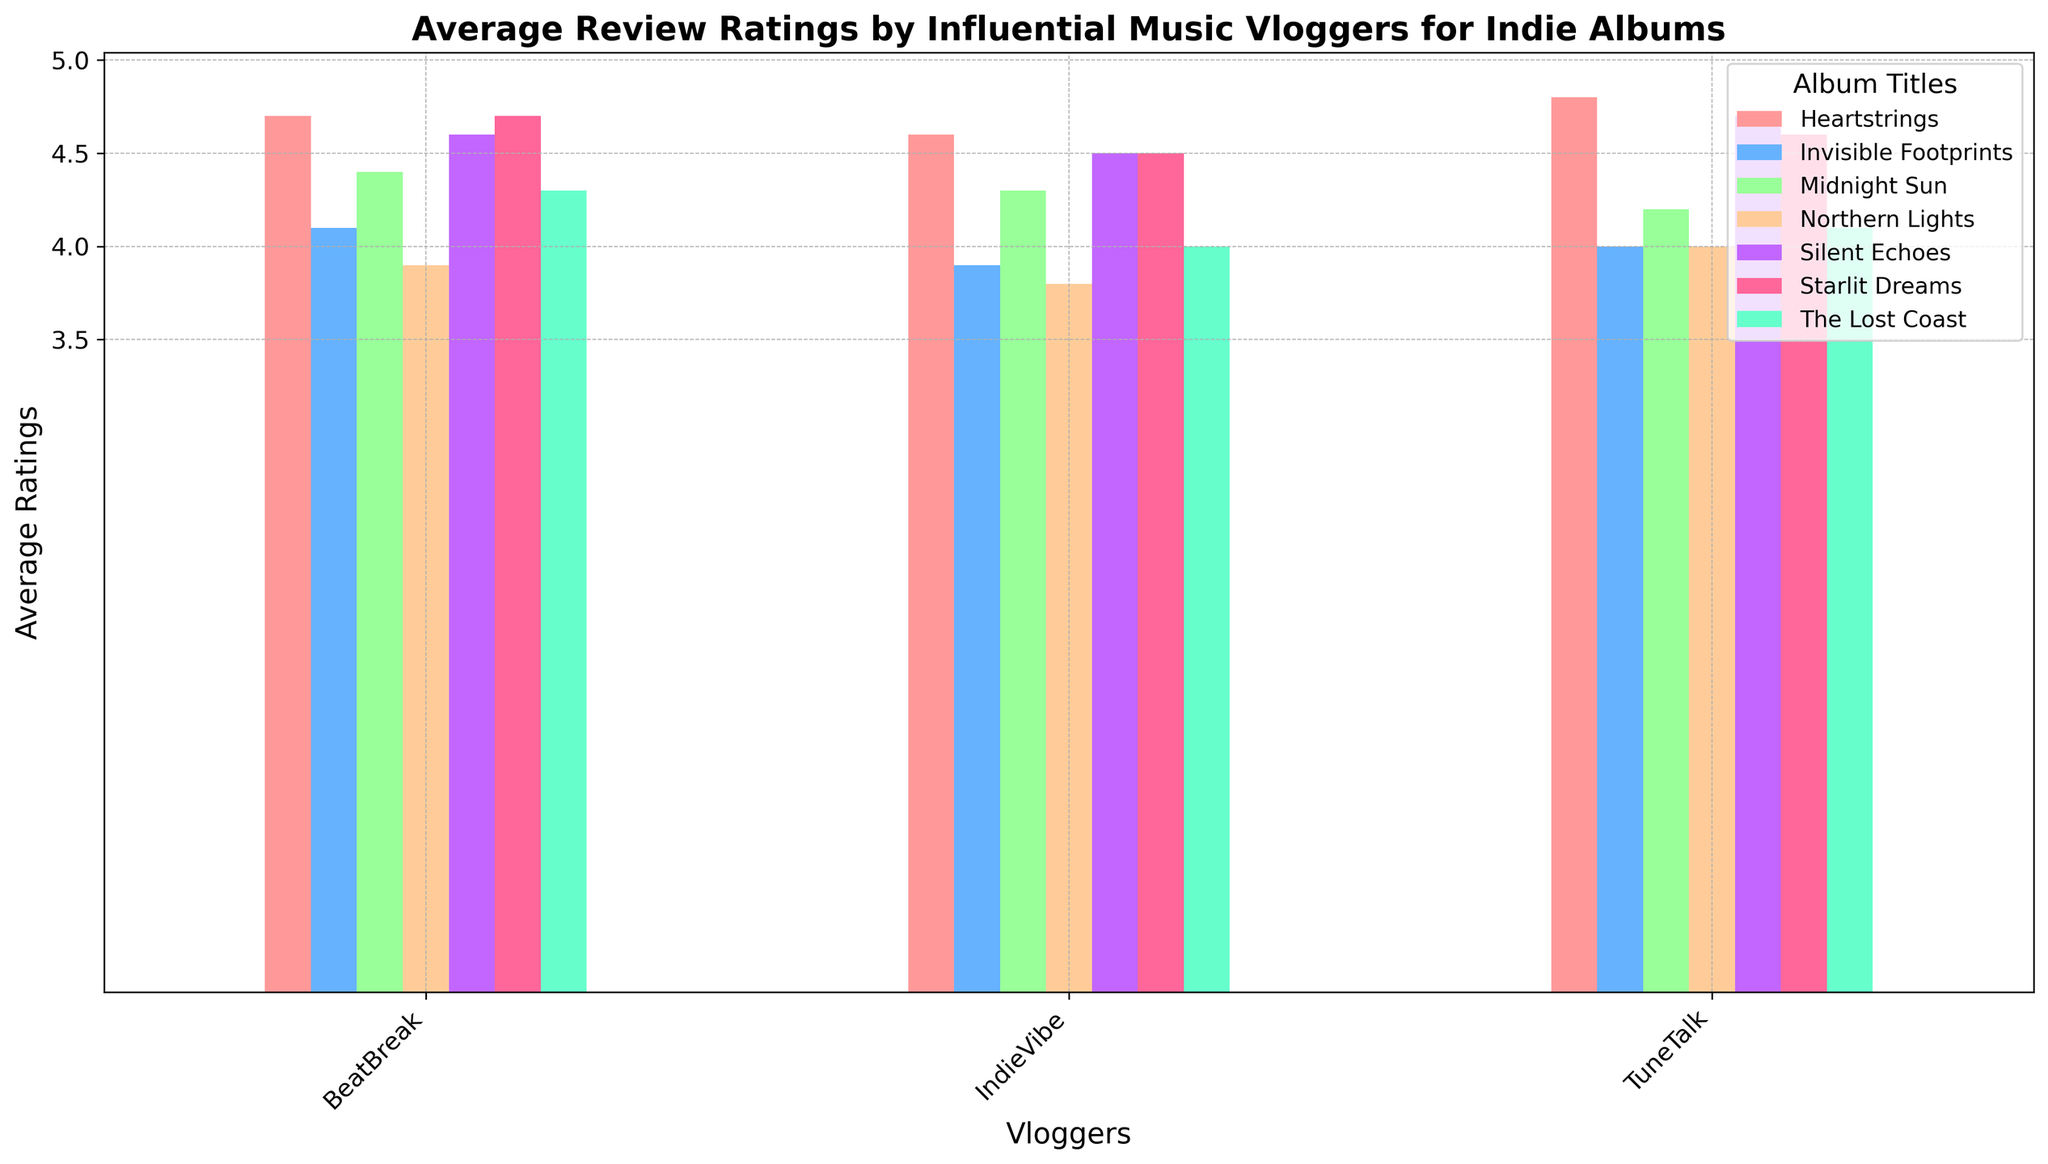What is the average rating given by IndieVibe for the album "Silent Echoes"? To find the average rating, look at the height of the bar corresponding to "Silent Echoes" for IndieVibe. According to the figure, the rating given by IndieVibe for "Silent Echoes" is clearly displayed.
Answer: 4.5 Which vlogger gave the highest rating for "Heartstrings"? Look at the height of the bars corresponding to "Heartstrings" for each vlogger. The tallest bar indicates the highest rating. In this case, TuneTalk has the highest bar for "Heartstrings".
Answer: TuneTalk Comparing "Midnight Sun" and "The Lost Coast", which album has higher average ratings from all vloggers combined? First, check each vlogger's rating for both albums and sum them up. "Midnight Sun": IndieVibe (4.3), TuneTalk (4.2), BeatBreak (4.4) sums to 12.9. "The Lost Coast": IndieVibe (4.0), TuneTalk (4.1), BeatBreak (4.3) sums to 12.4. Hence, "Midnight Sun" has higher combined ratings.
Answer: Midnight Sun What is the difference in ratings given by BeatBreak for "Starlit Dreams" and "Northern Lights"? Look at the height of the bars for "Starlit Dreams" and "Northern Lights" given by BeatBreak. Subtract the smaller bar height from the larger one: "Starlit Dreams" is 4.7, and "Northern Lights" is 3.9. 4.7 - 3.9 = 0.8.
Answer: 0.8 Identify the album with the lowest rating from all vloggers combined. Check each album's bar heights across all vloggers and note the lowest combined heights. "Northern Lights": IndieVibe (3.8), TuneTalk (4.0), BeatBreak (3.9) sums to 11.7, which seems to be the lowest among all albums.
Answer: Northern Lights Among "Invisible Footprints" and "Silent Echoes", which album received more consistent ratings across vloggers? To determine consistency, observe the variance in bar heights for each album. "Silent Echoes" (ratings: 4.5, 4.7, 4.6) shows less variance compared to "Invisible Footprints" (ratings: 3.9, 4.0, 4.1). Therefore, "Silent Echoes" has more consistent ratings.
Answer: Silent Echoes Which vlogger had the highest average rating across all albums? Calculate the average rating each vlogger gave by summing their ratings for all albums and dividing by the total number of albums they reviewed. IndieVibe: (4.5+4.0+3.8+4.6+4.3+3.9+4.5)/7 = 4.23, TuneTalk: (4.7+4.1+4.0+4.8+4.2+4.0+4.6)/7 = 4.34, BeatBreak: (4.6+4.3+3.9+4.7+4.4+4.1+4.7)/7 = 4.38. BeatBreak has the highest average rating.
Answer: BeatBreak 